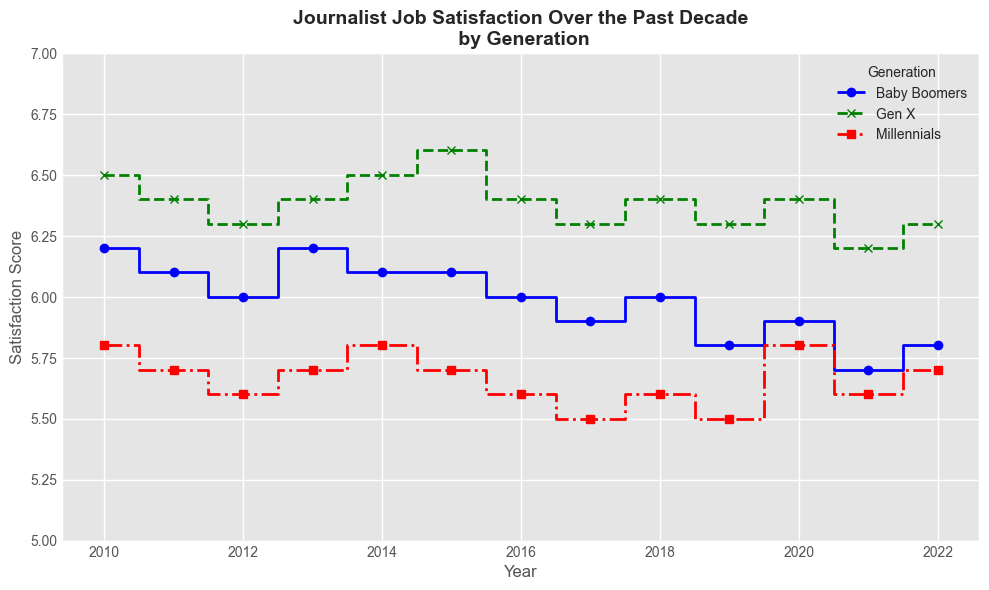What generation had the highest job satisfaction in 2013? Observe the plot for the year 2013 and note the satisfaction scores for each generation. The highest value corresponds to Gen X with about 6.4.
Answer: Gen X Which generation showed a consistent decrease in job satisfaction from 2011 to 2017? Observe the downward trend in the satisfaction scores over these years. Baby Boomers consistently decreased from 6.1 in 2011 to 5.9 in 2017.
Answer: Baby Boomers From 2017 to 2019, which generation had the steepest decrease in satisfaction score? Compare the differences between values for 2017 and 2019 for each generation. Millennials showed a decrease from 5.5 to 5.5, Gen X from 6.3 to 6.3, and Baby Boomers from 5.9 to 5.8. Despite all values being minimal, Baby Boomers had the observable decrease.
Answer: Baby Boomers Between which years did Millennials experience the biggest increase in satisfaction score? Observe the satisfaction scores for Millennials over the years and identify the biggest positive change. The score increased from 5.5 to 5.8 between 2019 and 2020.
Answer: 2019-2020 On average, which generation had the highest job satisfaction over the decade? Calculate the average satisfaction score for each generation over the years. Average each year’s satisfaction for Baby Boomers, Gen X, and Millennials across all years. Gen X has the highest average upon calculation.
Answer: Gen X How many years did Gen X have the highest satisfaction score when compared to Baby Boomers and Millennials? Count the number of years in the plot where Gen X's line is above both Baby Boomers' and Millennials'. This happens 11 times from 2010 to 2022.
Answer: 11 By how much did the satisfaction score for Baby Boomers decrease from 2010 to 2022? Compare the satisfaction scores of Baby Boomers in 2010 (6.2) and 2022 (5.8) and calculate the difference. 6.2 - 5.8 = 0.4
Answer: 0.4 Which generation's satisfaction score exhibited the most fluctuation over the decade? Observe the amplitude of changes in satisfaction scores over the years for each generation. Baby Boomers show the most variation ranging from 5.7 to 6.2, compared to the relative stability in Gen X and Millennials.
Answer: Baby Boomers 